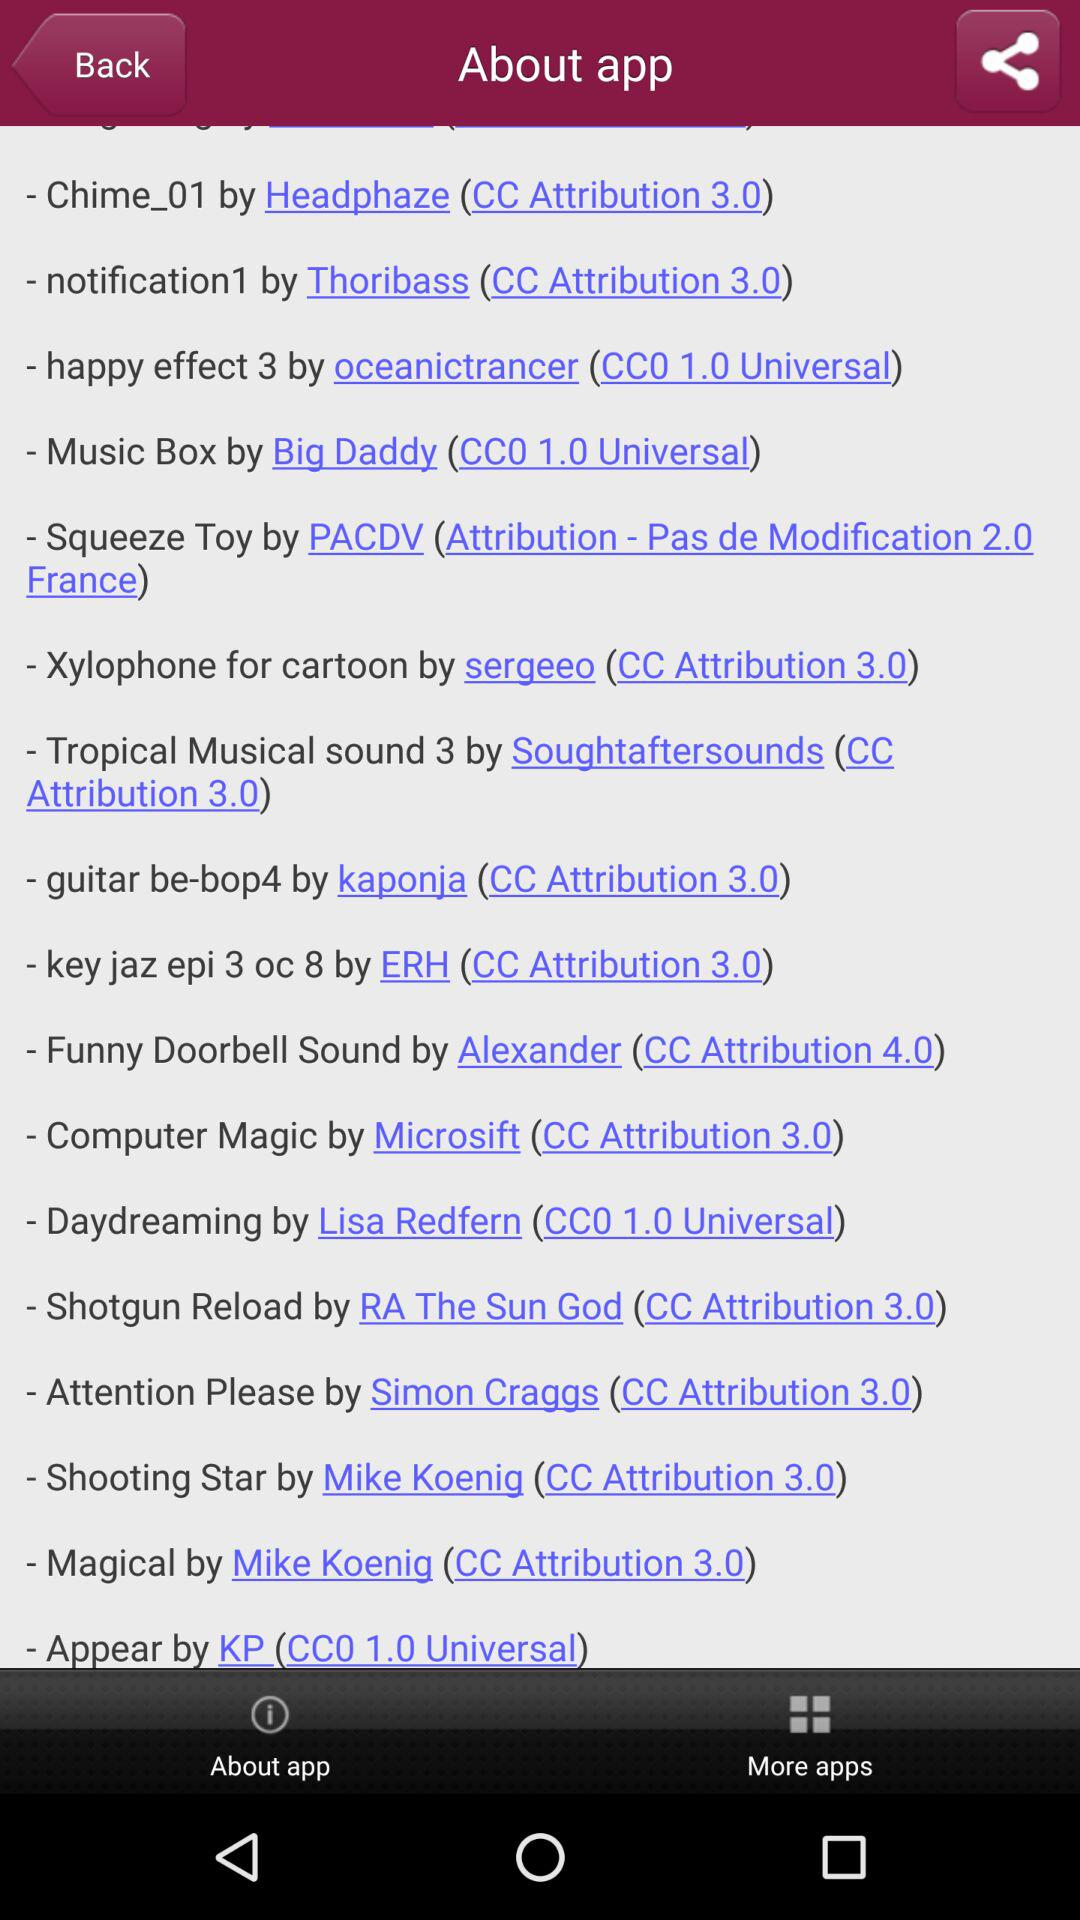Who is the developer of "Shotgun Reload"? It is developed by RA The Sun God. 